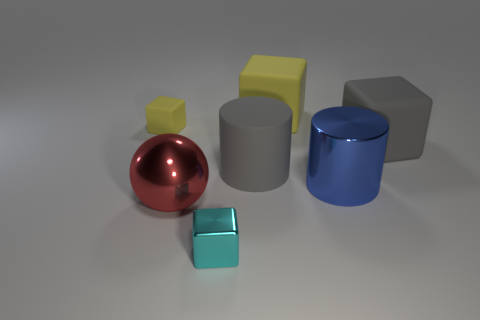Subtract all gray cubes. How many cubes are left? 3 Subtract all tiny cyan blocks. How many blocks are left? 3 Add 1 tiny yellow blocks. How many objects exist? 8 Subtract all blue cubes. Subtract all cyan spheres. How many cubes are left? 4 Subtract all spheres. How many objects are left? 6 Subtract all big purple cylinders. Subtract all metallic cubes. How many objects are left? 6 Add 5 rubber cylinders. How many rubber cylinders are left? 6 Add 6 gray cubes. How many gray cubes exist? 7 Subtract 0 purple cubes. How many objects are left? 7 